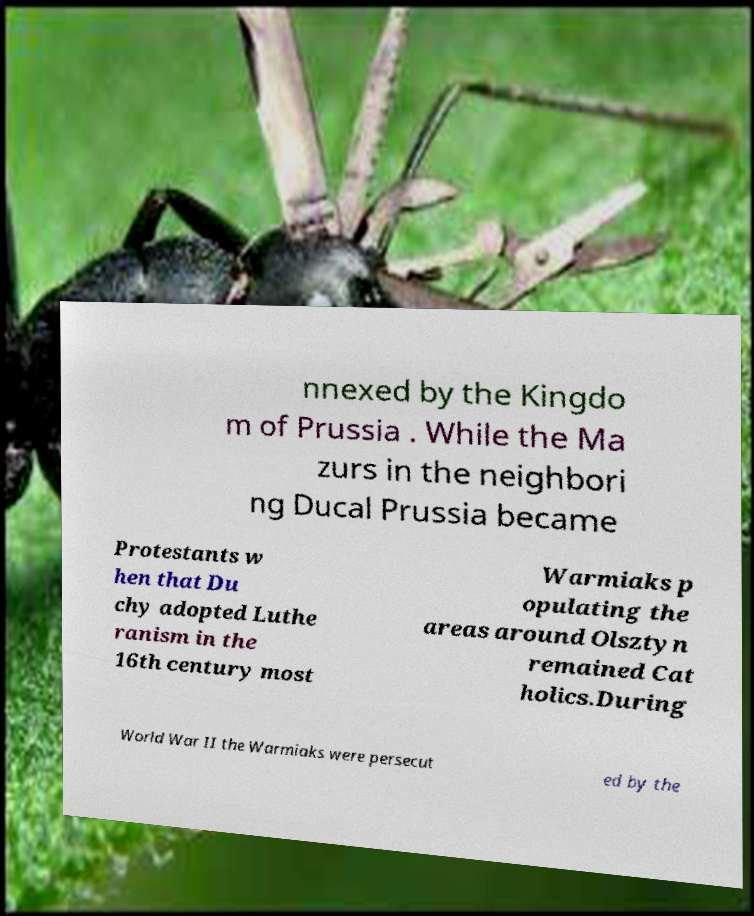Could you assist in decoding the text presented in this image and type it out clearly? nnexed by the Kingdo m of Prussia . While the Ma zurs in the neighbori ng Ducal Prussia became Protestants w hen that Du chy adopted Luthe ranism in the 16th century most Warmiaks p opulating the areas around Olsztyn remained Cat holics.During World War II the Warmiaks were persecut ed by the 